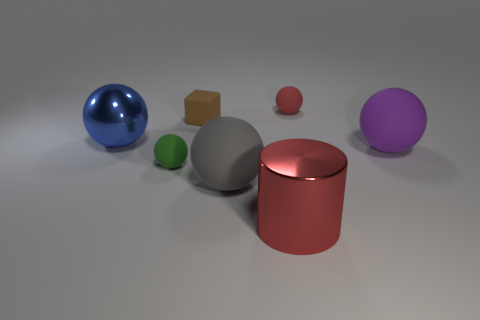Do the metal object to the right of the brown rubber object and the brown cube have the same size?
Provide a succinct answer. No. How many metal things are gray things or tiny blue balls?
Make the answer very short. 0. There is a tiny ball to the left of the brown rubber object; what number of brown rubber blocks are on the left side of it?
Offer a very short reply. 0. There is a large object that is both behind the green ball and right of the metal ball; what is its shape?
Offer a terse response. Sphere. The big thing that is behind the big rubber object behind the small object in front of the blue thing is made of what material?
Give a very brief answer. Metal. What is the size of the matte ball that is the same color as the large metallic cylinder?
Provide a short and direct response. Small. What is the big red object made of?
Provide a succinct answer. Metal. Is the small block made of the same material as the big thing that is to the right of the big red object?
Offer a very short reply. Yes. There is a large rubber object on the left side of the small object that is right of the large red metal cylinder; what color is it?
Provide a short and direct response. Gray. How big is the sphere that is both to the right of the red cylinder and in front of the blue metallic thing?
Offer a terse response. Large. 